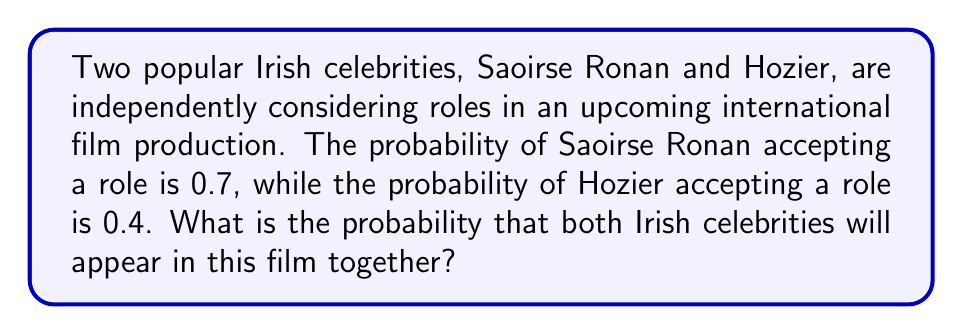Can you solve this math problem? To solve this problem, we need to use the multiplication rule of probability for independent events. Since Saoirse Ronan and Hozier are making their decisions independently, we can multiply their individual probabilities of accepting roles to find the probability of both appearing in the film.

Let's define our events:
$A$: Saoirse Ronan accepts a role
$B$: Hozier accepts a role

Given:
$P(A) = 0.7$
$P(B) = 0.4$

We want to find $P(A \text{ and } B)$, which is the probability of both events occurring.

For independent events, the probability of both events occurring is the product of their individual probabilities:

$$P(A \text{ and } B) = P(A) \times P(B)$$

Substituting the given probabilities:

$$P(A \text{ and } B) = 0.7 \times 0.4$$

Calculating:

$$P(A \text{ and } B) = 0.28$$

Therefore, the probability that both Saoirse Ronan and Hozier will appear in this film together is 0.28 or 28%.
Answer: $0.28$ or $28\%$ 